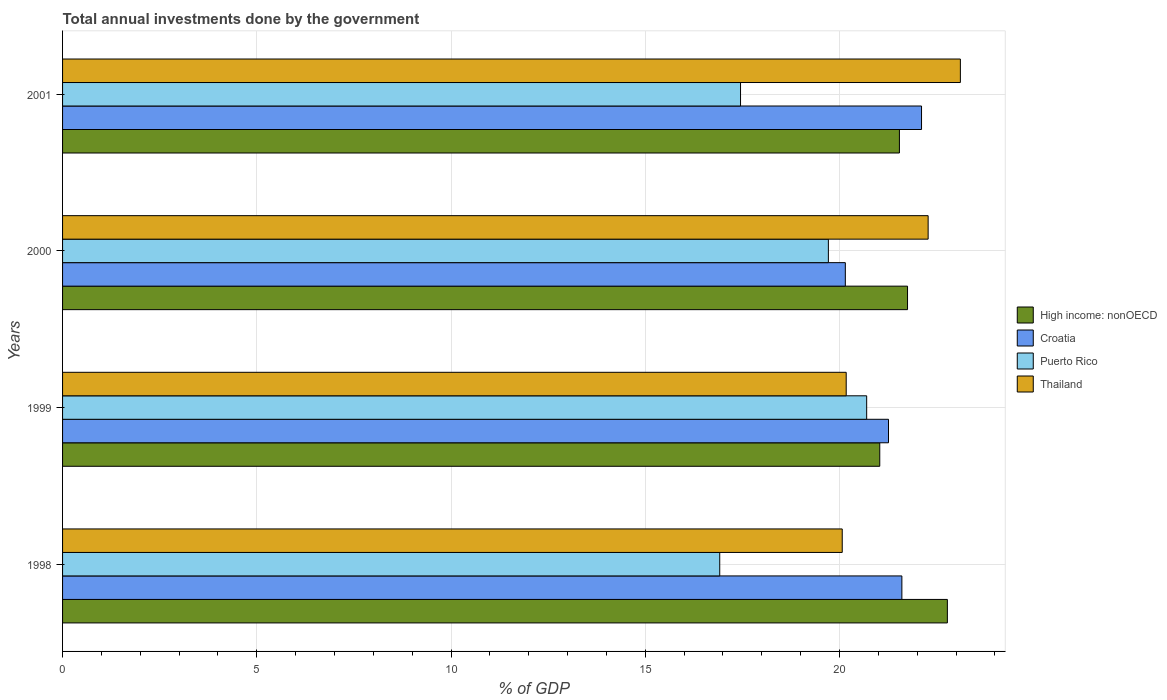How many different coloured bars are there?
Provide a succinct answer. 4. How many groups of bars are there?
Offer a terse response. 4. Are the number of bars per tick equal to the number of legend labels?
Make the answer very short. Yes. How many bars are there on the 2nd tick from the bottom?
Provide a short and direct response. 4. What is the label of the 2nd group of bars from the top?
Ensure brevity in your answer.  2000. In how many cases, is the number of bars for a given year not equal to the number of legend labels?
Offer a very short reply. 0. What is the total annual investments done by the government in Thailand in 2001?
Your answer should be compact. 23.11. Across all years, what is the maximum total annual investments done by the government in Thailand?
Give a very brief answer. 23.11. Across all years, what is the minimum total annual investments done by the government in High income: nonOECD?
Offer a very short reply. 21.04. In which year was the total annual investments done by the government in Thailand maximum?
Your answer should be compact. 2001. What is the total total annual investments done by the government in High income: nonOECD in the graph?
Your answer should be very brief. 87.11. What is the difference between the total annual investments done by the government in Puerto Rico in 1998 and that in 1999?
Your answer should be compact. -3.78. What is the difference between the total annual investments done by the government in Croatia in 1998 and the total annual investments done by the government in Puerto Rico in 1999?
Your answer should be very brief. 0.91. What is the average total annual investments done by the government in Thailand per year?
Keep it short and to the point. 21.41. In the year 2001, what is the difference between the total annual investments done by the government in High income: nonOECD and total annual investments done by the government in Croatia?
Offer a terse response. -0.57. In how many years, is the total annual investments done by the government in Thailand greater than 1 %?
Provide a succinct answer. 4. What is the ratio of the total annual investments done by the government in Puerto Rico in 1998 to that in 2000?
Make the answer very short. 0.86. Is the difference between the total annual investments done by the government in High income: nonOECD in 1998 and 1999 greater than the difference between the total annual investments done by the government in Croatia in 1998 and 1999?
Provide a short and direct response. Yes. What is the difference between the highest and the second highest total annual investments done by the government in Thailand?
Your answer should be very brief. 0.83. What is the difference between the highest and the lowest total annual investments done by the government in High income: nonOECD?
Ensure brevity in your answer.  1.74. In how many years, is the total annual investments done by the government in High income: nonOECD greater than the average total annual investments done by the government in High income: nonOECD taken over all years?
Make the answer very short. 1. What does the 2nd bar from the top in 1998 represents?
Your answer should be compact. Puerto Rico. What does the 4th bar from the bottom in 2000 represents?
Provide a succinct answer. Thailand. How many bars are there?
Your answer should be very brief. 16. Are all the bars in the graph horizontal?
Your response must be concise. Yes. Does the graph contain any zero values?
Ensure brevity in your answer.  No. Does the graph contain grids?
Make the answer very short. Yes. Where does the legend appear in the graph?
Ensure brevity in your answer.  Center right. How are the legend labels stacked?
Your response must be concise. Vertical. What is the title of the graph?
Your answer should be compact. Total annual investments done by the government. What is the label or title of the X-axis?
Make the answer very short. % of GDP. What is the % of GDP of High income: nonOECD in 1998?
Provide a succinct answer. 22.78. What is the % of GDP of Croatia in 1998?
Keep it short and to the point. 21.61. What is the % of GDP of Puerto Rico in 1998?
Give a very brief answer. 16.92. What is the % of GDP in Thailand in 1998?
Provide a succinct answer. 20.07. What is the % of GDP of High income: nonOECD in 1999?
Offer a very short reply. 21.04. What is the % of GDP of Croatia in 1999?
Provide a succinct answer. 21.26. What is the % of GDP of Puerto Rico in 1999?
Your response must be concise. 20.7. What is the % of GDP of Thailand in 1999?
Ensure brevity in your answer.  20.17. What is the % of GDP in High income: nonOECD in 2000?
Provide a succinct answer. 21.75. What is the % of GDP in Croatia in 2000?
Your answer should be very brief. 20.15. What is the % of GDP of Puerto Rico in 2000?
Your response must be concise. 19.71. What is the % of GDP of Thailand in 2000?
Provide a short and direct response. 22.28. What is the % of GDP in High income: nonOECD in 2001?
Your answer should be compact. 21.54. What is the % of GDP of Croatia in 2001?
Your answer should be compact. 22.11. What is the % of GDP in Puerto Rico in 2001?
Ensure brevity in your answer.  17.45. What is the % of GDP of Thailand in 2001?
Your answer should be very brief. 23.11. Across all years, what is the maximum % of GDP in High income: nonOECD?
Offer a terse response. 22.78. Across all years, what is the maximum % of GDP of Croatia?
Your response must be concise. 22.11. Across all years, what is the maximum % of GDP of Puerto Rico?
Provide a succinct answer. 20.7. Across all years, what is the maximum % of GDP in Thailand?
Ensure brevity in your answer.  23.11. Across all years, what is the minimum % of GDP of High income: nonOECD?
Give a very brief answer. 21.04. Across all years, what is the minimum % of GDP in Croatia?
Offer a very short reply. 20.15. Across all years, what is the minimum % of GDP of Puerto Rico?
Provide a short and direct response. 16.92. Across all years, what is the minimum % of GDP of Thailand?
Ensure brevity in your answer.  20.07. What is the total % of GDP in High income: nonOECD in the graph?
Ensure brevity in your answer.  87.11. What is the total % of GDP in Croatia in the graph?
Keep it short and to the point. 85.13. What is the total % of GDP of Puerto Rico in the graph?
Provide a short and direct response. 74.79. What is the total % of GDP of Thailand in the graph?
Your answer should be very brief. 85.64. What is the difference between the % of GDP in High income: nonOECD in 1998 and that in 1999?
Make the answer very short. 1.74. What is the difference between the % of GDP in Croatia in 1998 and that in 1999?
Your answer should be very brief. 0.34. What is the difference between the % of GDP of Puerto Rico in 1998 and that in 1999?
Provide a short and direct response. -3.78. What is the difference between the % of GDP in Thailand in 1998 and that in 1999?
Your response must be concise. -0.1. What is the difference between the % of GDP in High income: nonOECD in 1998 and that in 2000?
Your answer should be very brief. 1.03. What is the difference between the % of GDP of Croatia in 1998 and that in 2000?
Keep it short and to the point. 1.46. What is the difference between the % of GDP of Puerto Rico in 1998 and that in 2000?
Offer a very short reply. -2.8. What is the difference between the % of GDP of Thailand in 1998 and that in 2000?
Give a very brief answer. -2.21. What is the difference between the % of GDP in High income: nonOECD in 1998 and that in 2001?
Provide a short and direct response. 1.23. What is the difference between the % of GDP in Croatia in 1998 and that in 2001?
Your response must be concise. -0.51. What is the difference between the % of GDP in Puerto Rico in 1998 and that in 2001?
Provide a short and direct response. -0.54. What is the difference between the % of GDP of Thailand in 1998 and that in 2001?
Ensure brevity in your answer.  -3.04. What is the difference between the % of GDP of High income: nonOECD in 1999 and that in 2000?
Your response must be concise. -0.71. What is the difference between the % of GDP of Croatia in 1999 and that in 2000?
Give a very brief answer. 1.11. What is the difference between the % of GDP in Puerto Rico in 1999 and that in 2000?
Make the answer very short. 0.99. What is the difference between the % of GDP in Thailand in 1999 and that in 2000?
Your answer should be compact. -2.11. What is the difference between the % of GDP in High income: nonOECD in 1999 and that in 2001?
Provide a short and direct response. -0.51. What is the difference between the % of GDP in Croatia in 1999 and that in 2001?
Your answer should be compact. -0.85. What is the difference between the % of GDP of Puerto Rico in 1999 and that in 2001?
Your answer should be compact. 3.25. What is the difference between the % of GDP in Thailand in 1999 and that in 2001?
Your answer should be very brief. -2.94. What is the difference between the % of GDP of High income: nonOECD in 2000 and that in 2001?
Provide a succinct answer. 0.21. What is the difference between the % of GDP of Croatia in 2000 and that in 2001?
Your answer should be compact. -1.96. What is the difference between the % of GDP in Puerto Rico in 2000 and that in 2001?
Give a very brief answer. 2.26. What is the difference between the % of GDP of Thailand in 2000 and that in 2001?
Your response must be concise. -0.83. What is the difference between the % of GDP in High income: nonOECD in 1998 and the % of GDP in Croatia in 1999?
Your answer should be very brief. 1.52. What is the difference between the % of GDP in High income: nonOECD in 1998 and the % of GDP in Puerto Rico in 1999?
Provide a succinct answer. 2.08. What is the difference between the % of GDP in High income: nonOECD in 1998 and the % of GDP in Thailand in 1999?
Give a very brief answer. 2.6. What is the difference between the % of GDP in Croatia in 1998 and the % of GDP in Puerto Rico in 1999?
Your answer should be compact. 0.91. What is the difference between the % of GDP in Croatia in 1998 and the % of GDP in Thailand in 1999?
Keep it short and to the point. 1.43. What is the difference between the % of GDP of Puerto Rico in 1998 and the % of GDP of Thailand in 1999?
Offer a terse response. -3.26. What is the difference between the % of GDP of High income: nonOECD in 1998 and the % of GDP of Croatia in 2000?
Your answer should be very brief. 2.63. What is the difference between the % of GDP of High income: nonOECD in 1998 and the % of GDP of Puerto Rico in 2000?
Keep it short and to the point. 3.06. What is the difference between the % of GDP in High income: nonOECD in 1998 and the % of GDP in Thailand in 2000?
Offer a very short reply. 0.5. What is the difference between the % of GDP of Croatia in 1998 and the % of GDP of Puerto Rico in 2000?
Your answer should be very brief. 1.89. What is the difference between the % of GDP in Croatia in 1998 and the % of GDP in Thailand in 2000?
Your answer should be compact. -0.68. What is the difference between the % of GDP of Puerto Rico in 1998 and the % of GDP of Thailand in 2000?
Ensure brevity in your answer.  -5.37. What is the difference between the % of GDP in High income: nonOECD in 1998 and the % of GDP in Croatia in 2001?
Offer a terse response. 0.67. What is the difference between the % of GDP in High income: nonOECD in 1998 and the % of GDP in Puerto Rico in 2001?
Your response must be concise. 5.33. What is the difference between the % of GDP in High income: nonOECD in 1998 and the % of GDP in Thailand in 2001?
Your response must be concise. -0.33. What is the difference between the % of GDP in Croatia in 1998 and the % of GDP in Puerto Rico in 2001?
Your answer should be compact. 4.15. What is the difference between the % of GDP of Croatia in 1998 and the % of GDP of Thailand in 2001?
Your response must be concise. -1.51. What is the difference between the % of GDP in Puerto Rico in 1998 and the % of GDP in Thailand in 2001?
Your answer should be compact. -6.19. What is the difference between the % of GDP of High income: nonOECD in 1999 and the % of GDP of Croatia in 2000?
Offer a terse response. 0.89. What is the difference between the % of GDP in High income: nonOECD in 1999 and the % of GDP in Puerto Rico in 2000?
Offer a very short reply. 1.32. What is the difference between the % of GDP of High income: nonOECD in 1999 and the % of GDP of Thailand in 2000?
Provide a short and direct response. -1.25. What is the difference between the % of GDP in Croatia in 1999 and the % of GDP in Puerto Rico in 2000?
Provide a succinct answer. 1.55. What is the difference between the % of GDP in Croatia in 1999 and the % of GDP in Thailand in 2000?
Provide a short and direct response. -1.02. What is the difference between the % of GDP of Puerto Rico in 1999 and the % of GDP of Thailand in 2000?
Give a very brief answer. -1.58. What is the difference between the % of GDP in High income: nonOECD in 1999 and the % of GDP in Croatia in 2001?
Make the answer very short. -1.08. What is the difference between the % of GDP of High income: nonOECD in 1999 and the % of GDP of Puerto Rico in 2001?
Keep it short and to the point. 3.58. What is the difference between the % of GDP in High income: nonOECD in 1999 and the % of GDP in Thailand in 2001?
Your answer should be very brief. -2.08. What is the difference between the % of GDP in Croatia in 1999 and the % of GDP in Puerto Rico in 2001?
Provide a short and direct response. 3.81. What is the difference between the % of GDP of Croatia in 1999 and the % of GDP of Thailand in 2001?
Make the answer very short. -1.85. What is the difference between the % of GDP in Puerto Rico in 1999 and the % of GDP in Thailand in 2001?
Give a very brief answer. -2.41. What is the difference between the % of GDP in High income: nonOECD in 2000 and the % of GDP in Croatia in 2001?
Ensure brevity in your answer.  -0.36. What is the difference between the % of GDP in High income: nonOECD in 2000 and the % of GDP in Puerto Rico in 2001?
Keep it short and to the point. 4.3. What is the difference between the % of GDP in High income: nonOECD in 2000 and the % of GDP in Thailand in 2001?
Your answer should be compact. -1.36. What is the difference between the % of GDP in Croatia in 2000 and the % of GDP in Puerto Rico in 2001?
Give a very brief answer. 2.7. What is the difference between the % of GDP of Croatia in 2000 and the % of GDP of Thailand in 2001?
Your answer should be compact. -2.96. What is the difference between the % of GDP of Puerto Rico in 2000 and the % of GDP of Thailand in 2001?
Your answer should be very brief. -3.4. What is the average % of GDP in High income: nonOECD per year?
Your answer should be compact. 21.78. What is the average % of GDP in Croatia per year?
Provide a short and direct response. 21.28. What is the average % of GDP of Puerto Rico per year?
Keep it short and to the point. 18.7. What is the average % of GDP in Thailand per year?
Provide a succinct answer. 21.41. In the year 1998, what is the difference between the % of GDP in High income: nonOECD and % of GDP in Croatia?
Your response must be concise. 1.17. In the year 1998, what is the difference between the % of GDP of High income: nonOECD and % of GDP of Puerto Rico?
Provide a short and direct response. 5.86. In the year 1998, what is the difference between the % of GDP in High income: nonOECD and % of GDP in Thailand?
Offer a very short reply. 2.71. In the year 1998, what is the difference between the % of GDP of Croatia and % of GDP of Puerto Rico?
Offer a very short reply. 4.69. In the year 1998, what is the difference between the % of GDP of Croatia and % of GDP of Thailand?
Your response must be concise. 1.54. In the year 1998, what is the difference between the % of GDP of Puerto Rico and % of GDP of Thailand?
Provide a short and direct response. -3.15. In the year 1999, what is the difference between the % of GDP of High income: nonOECD and % of GDP of Croatia?
Ensure brevity in your answer.  -0.23. In the year 1999, what is the difference between the % of GDP in High income: nonOECD and % of GDP in Puerto Rico?
Provide a succinct answer. 0.34. In the year 1999, what is the difference between the % of GDP of High income: nonOECD and % of GDP of Thailand?
Offer a very short reply. 0.86. In the year 1999, what is the difference between the % of GDP in Croatia and % of GDP in Puerto Rico?
Your response must be concise. 0.56. In the year 1999, what is the difference between the % of GDP of Croatia and % of GDP of Thailand?
Your response must be concise. 1.09. In the year 1999, what is the difference between the % of GDP of Puerto Rico and % of GDP of Thailand?
Give a very brief answer. 0.53. In the year 2000, what is the difference between the % of GDP in High income: nonOECD and % of GDP in Croatia?
Your answer should be compact. 1.6. In the year 2000, what is the difference between the % of GDP in High income: nonOECD and % of GDP in Puerto Rico?
Give a very brief answer. 2.04. In the year 2000, what is the difference between the % of GDP of High income: nonOECD and % of GDP of Thailand?
Your response must be concise. -0.53. In the year 2000, what is the difference between the % of GDP in Croatia and % of GDP in Puerto Rico?
Make the answer very short. 0.44. In the year 2000, what is the difference between the % of GDP in Croatia and % of GDP in Thailand?
Provide a succinct answer. -2.13. In the year 2000, what is the difference between the % of GDP in Puerto Rico and % of GDP in Thailand?
Offer a terse response. -2.57. In the year 2001, what is the difference between the % of GDP in High income: nonOECD and % of GDP in Croatia?
Provide a succinct answer. -0.57. In the year 2001, what is the difference between the % of GDP in High income: nonOECD and % of GDP in Puerto Rico?
Ensure brevity in your answer.  4.09. In the year 2001, what is the difference between the % of GDP in High income: nonOECD and % of GDP in Thailand?
Keep it short and to the point. -1.57. In the year 2001, what is the difference between the % of GDP in Croatia and % of GDP in Puerto Rico?
Make the answer very short. 4.66. In the year 2001, what is the difference between the % of GDP in Croatia and % of GDP in Thailand?
Offer a very short reply. -1. In the year 2001, what is the difference between the % of GDP of Puerto Rico and % of GDP of Thailand?
Offer a very short reply. -5.66. What is the ratio of the % of GDP of High income: nonOECD in 1998 to that in 1999?
Provide a succinct answer. 1.08. What is the ratio of the % of GDP in Croatia in 1998 to that in 1999?
Your answer should be compact. 1.02. What is the ratio of the % of GDP in Puerto Rico in 1998 to that in 1999?
Ensure brevity in your answer.  0.82. What is the ratio of the % of GDP in Thailand in 1998 to that in 1999?
Give a very brief answer. 0.99. What is the ratio of the % of GDP in High income: nonOECD in 1998 to that in 2000?
Give a very brief answer. 1.05. What is the ratio of the % of GDP in Croatia in 1998 to that in 2000?
Your answer should be very brief. 1.07. What is the ratio of the % of GDP in Puerto Rico in 1998 to that in 2000?
Provide a short and direct response. 0.86. What is the ratio of the % of GDP of Thailand in 1998 to that in 2000?
Provide a short and direct response. 0.9. What is the ratio of the % of GDP in High income: nonOECD in 1998 to that in 2001?
Offer a terse response. 1.06. What is the ratio of the % of GDP of Croatia in 1998 to that in 2001?
Your answer should be compact. 0.98. What is the ratio of the % of GDP of Puerto Rico in 1998 to that in 2001?
Offer a terse response. 0.97. What is the ratio of the % of GDP of Thailand in 1998 to that in 2001?
Provide a short and direct response. 0.87. What is the ratio of the % of GDP of High income: nonOECD in 1999 to that in 2000?
Offer a terse response. 0.97. What is the ratio of the % of GDP in Croatia in 1999 to that in 2000?
Keep it short and to the point. 1.06. What is the ratio of the % of GDP of Thailand in 1999 to that in 2000?
Keep it short and to the point. 0.91. What is the ratio of the % of GDP of High income: nonOECD in 1999 to that in 2001?
Your answer should be compact. 0.98. What is the ratio of the % of GDP of Croatia in 1999 to that in 2001?
Keep it short and to the point. 0.96. What is the ratio of the % of GDP in Puerto Rico in 1999 to that in 2001?
Keep it short and to the point. 1.19. What is the ratio of the % of GDP of Thailand in 1999 to that in 2001?
Your answer should be very brief. 0.87. What is the ratio of the % of GDP in High income: nonOECD in 2000 to that in 2001?
Provide a short and direct response. 1.01. What is the ratio of the % of GDP in Croatia in 2000 to that in 2001?
Offer a very short reply. 0.91. What is the ratio of the % of GDP of Puerto Rico in 2000 to that in 2001?
Offer a terse response. 1.13. What is the ratio of the % of GDP in Thailand in 2000 to that in 2001?
Offer a very short reply. 0.96. What is the difference between the highest and the second highest % of GDP in High income: nonOECD?
Your answer should be compact. 1.03. What is the difference between the highest and the second highest % of GDP in Croatia?
Make the answer very short. 0.51. What is the difference between the highest and the second highest % of GDP of Puerto Rico?
Your answer should be compact. 0.99. What is the difference between the highest and the second highest % of GDP of Thailand?
Your answer should be compact. 0.83. What is the difference between the highest and the lowest % of GDP in High income: nonOECD?
Give a very brief answer. 1.74. What is the difference between the highest and the lowest % of GDP of Croatia?
Keep it short and to the point. 1.96. What is the difference between the highest and the lowest % of GDP in Puerto Rico?
Make the answer very short. 3.78. What is the difference between the highest and the lowest % of GDP in Thailand?
Your answer should be very brief. 3.04. 